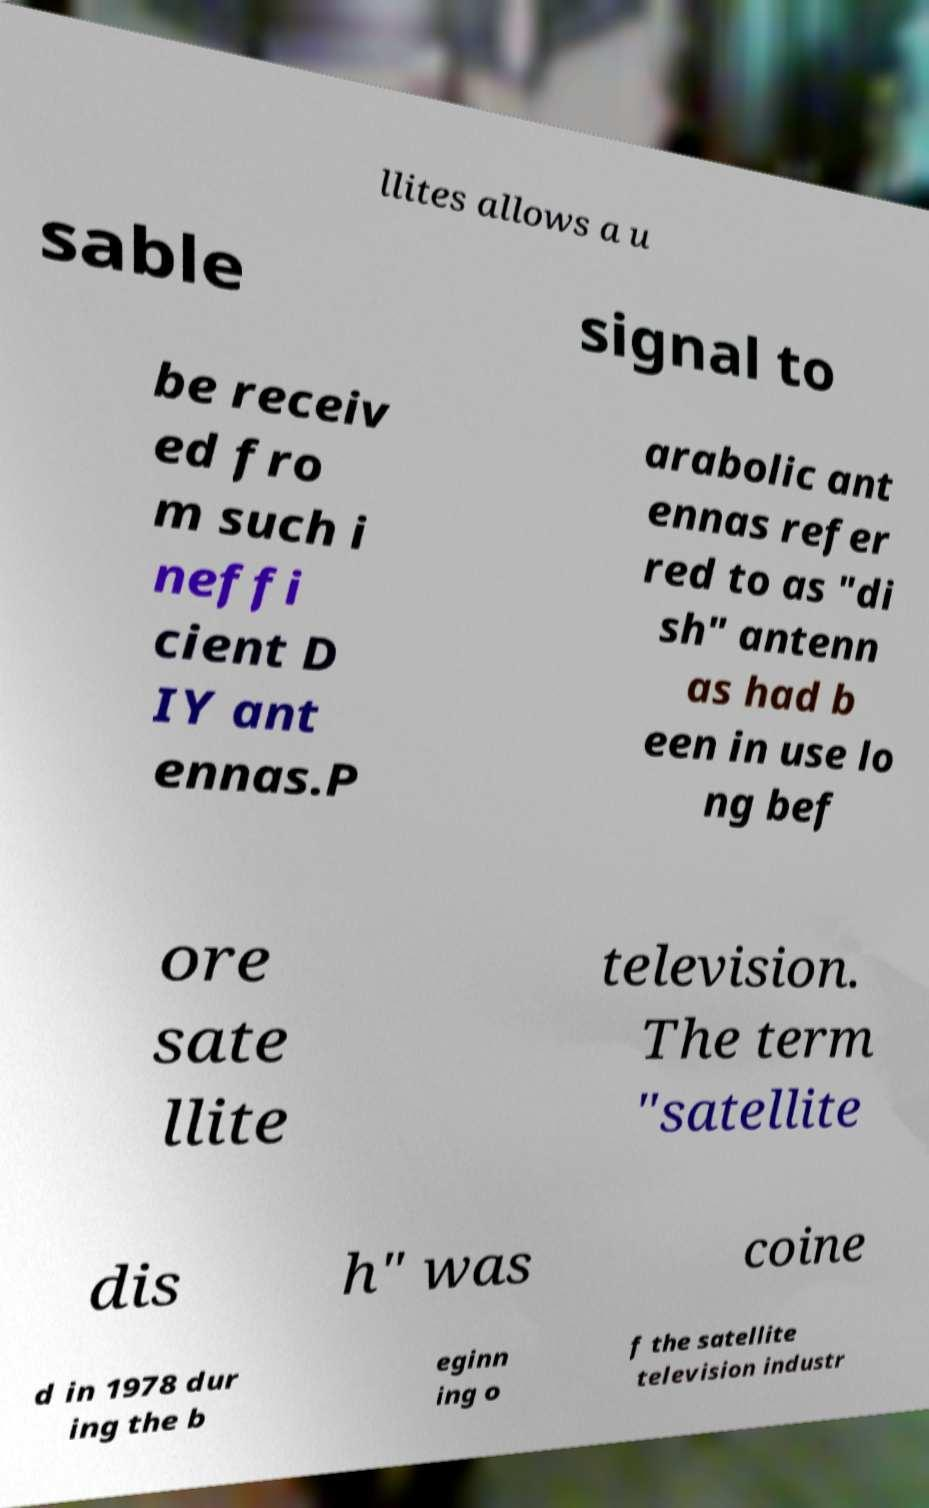Please identify and transcribe the text found in this image. llites allows a u sable signal to be receiv ed fro m such i neffi cient D IY ant ennas.P arabolic ant ennas refer red to as "di sh" antenn as had b een in use lo ng bef ore sate llite television. The term "satellite dis h" was coine d in 1978 dur ing the b eginn ing o f the satellite television industr 